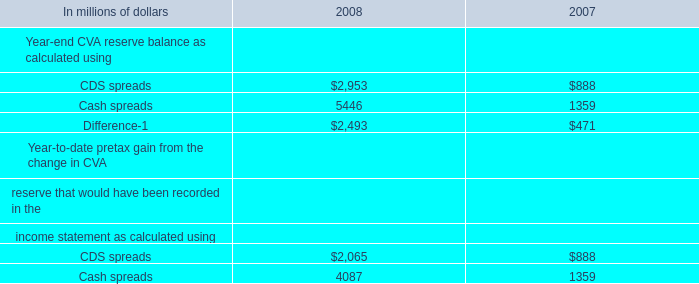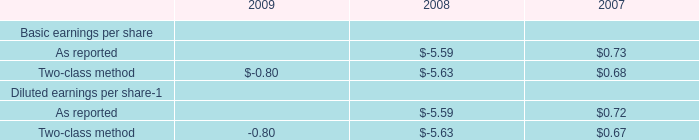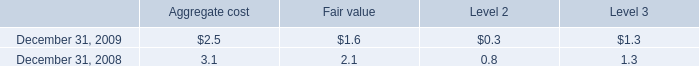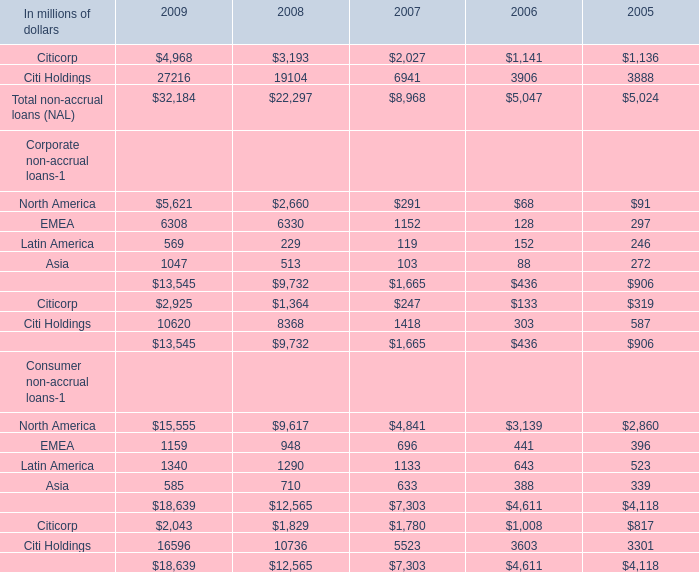If Total non-accrual loans (NAL) develops with the same growth rate in 2009, what will it reach in 2010? (in million) 
Computations: (32184 * (1 + ((32184 - 22297) / 22297)))
Answer: 46455.12203. 